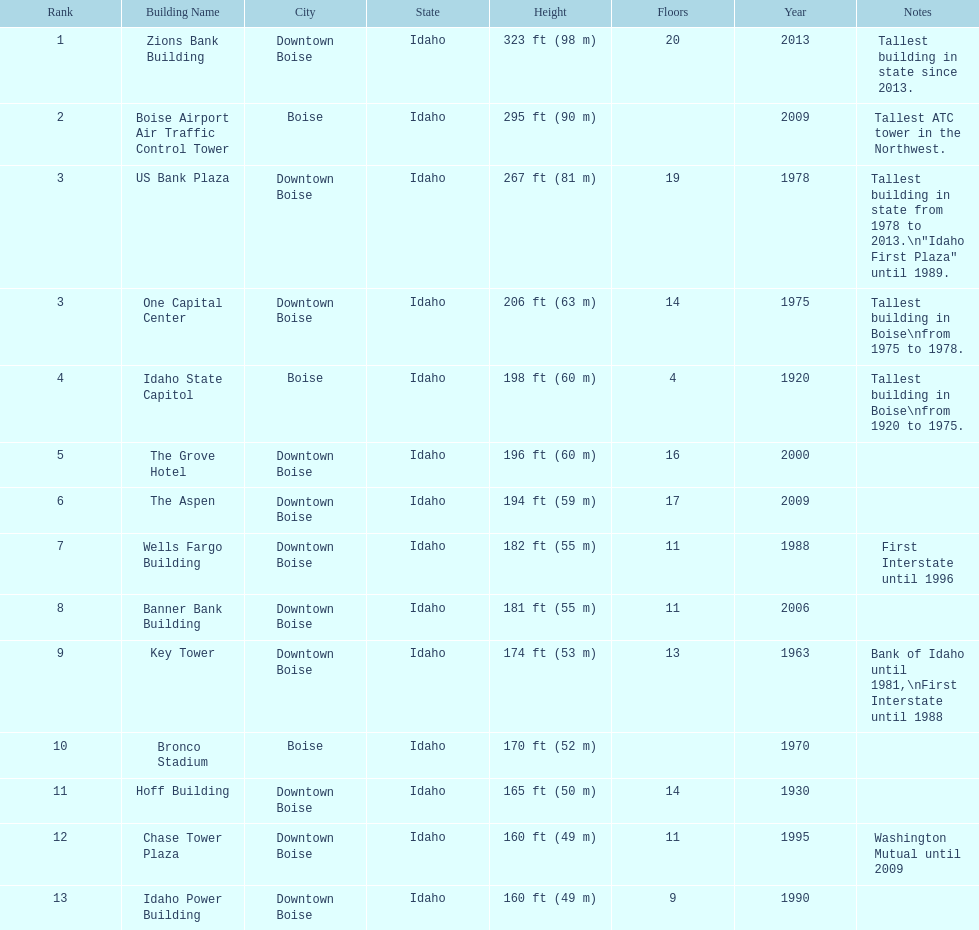How tall (in meters) is the tallest building? 98 m. 